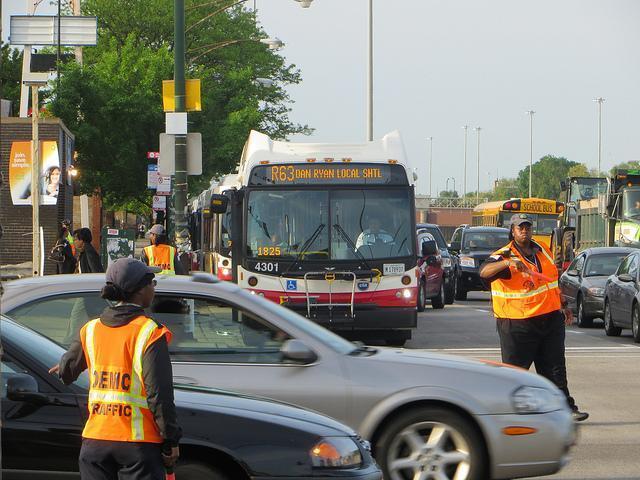How many people are directing traffic?
Give a very brief answer. 3. How many people are in the picture?
Give a very brief answer. 2. How many buses can be seen?
Give a very brief answer. 3. How many cars are there?
Give a very brief answer. 4. 